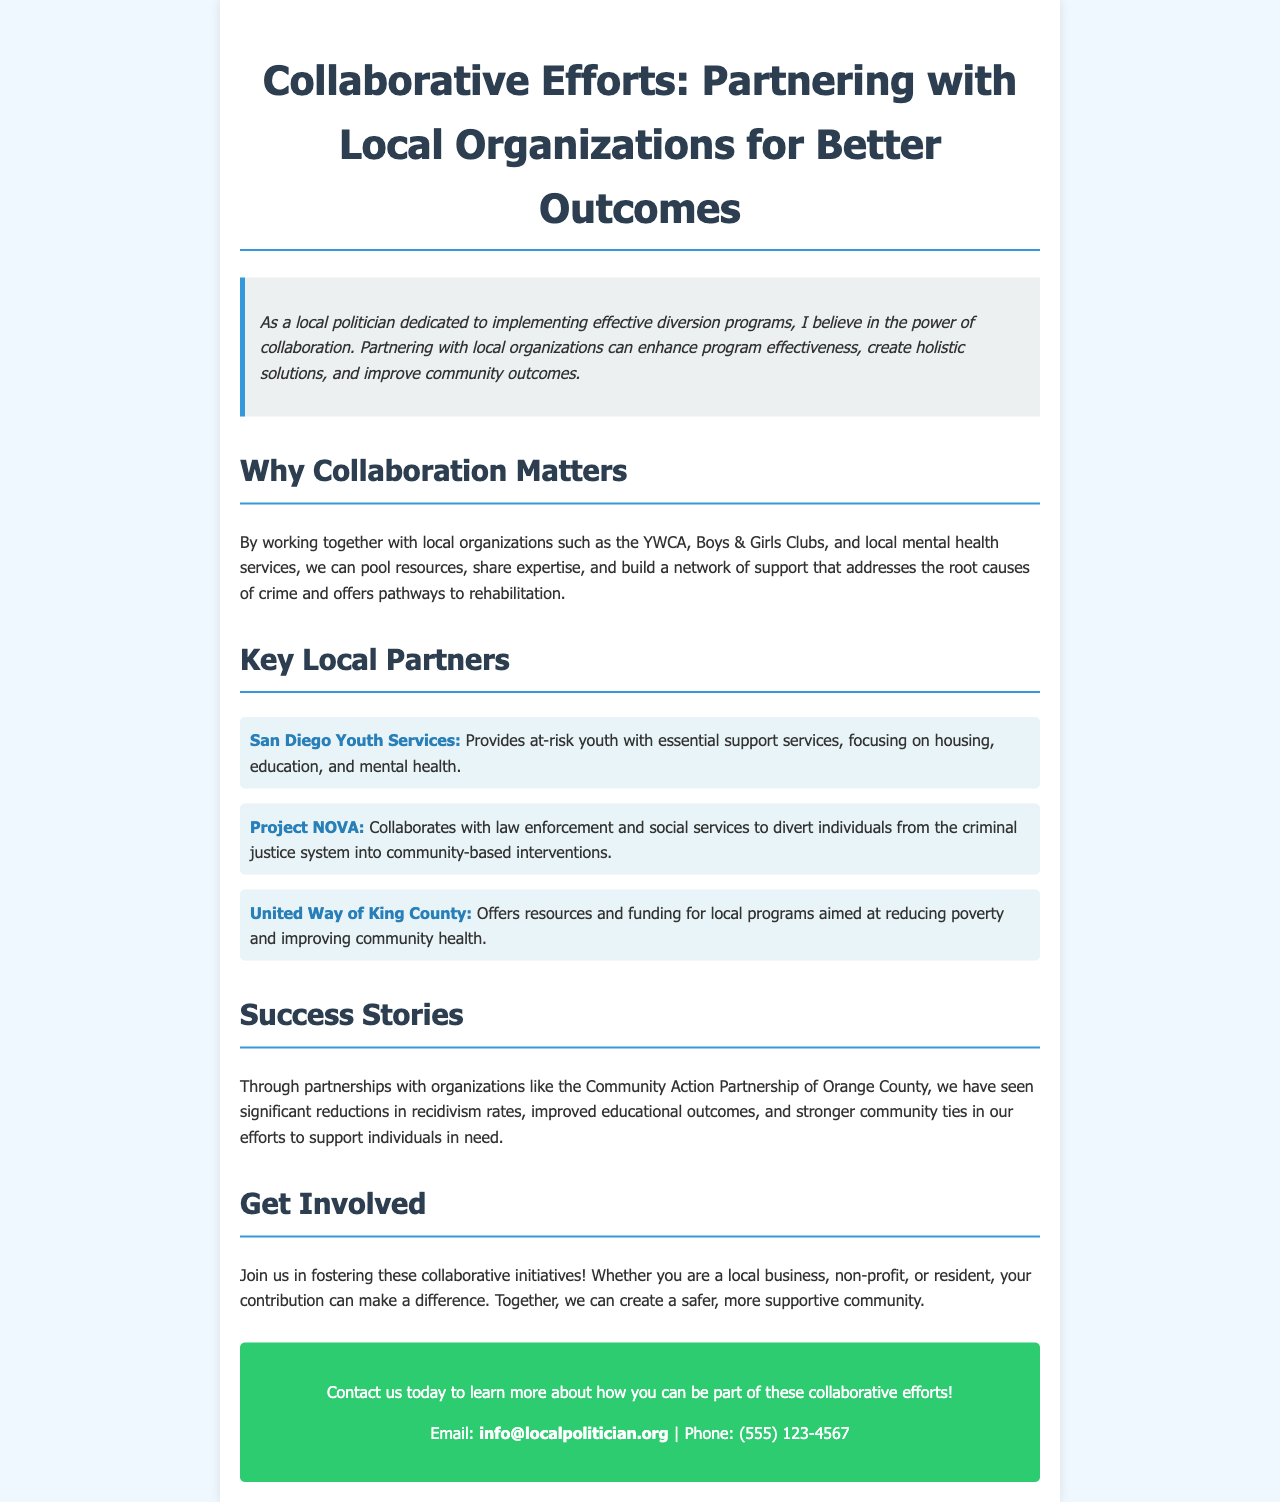What is the main focus of the brochure? The brochure emphasizes the importance of collaboration between local organizations to enhance diversion programs and community outcomes.
Answer: Collaboration Which organization provides support services to at-risk youth? The document lists San Diego Youth Services as providing essential support services for at-risk youth.
Answer: San Diego Youth Services What is the contact email for inquiries? The email address provided for contact in the brochure is essential for interested individuals to reach out.
Answer: info@localpolitician.org Which local organization collaborates with law enforcement to divert individuals? The brochure mentions Project NOVA, which works with law enforcement and social services to provide community-based interventions.
Answer: Project NOVA What are the overall benefits of collaborative efforts mentioned? It highlights improvements in recidivism rates, educational outcomes, and community ties through collaboration.
Answer: Improved outcomes How many key local partners are listed in the document? The brochure enumerates three key local partners that contribute to the collaborative efforts.
Answer: Three 